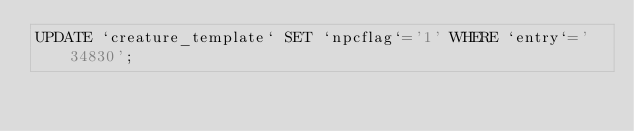Convert code to text. <code><loc_0><loc_0><loc_500><loc_500><_SQL_>UPDATE `creature_template` SET `npcflag`='1' WHERE `entry`='34830';
</code> 